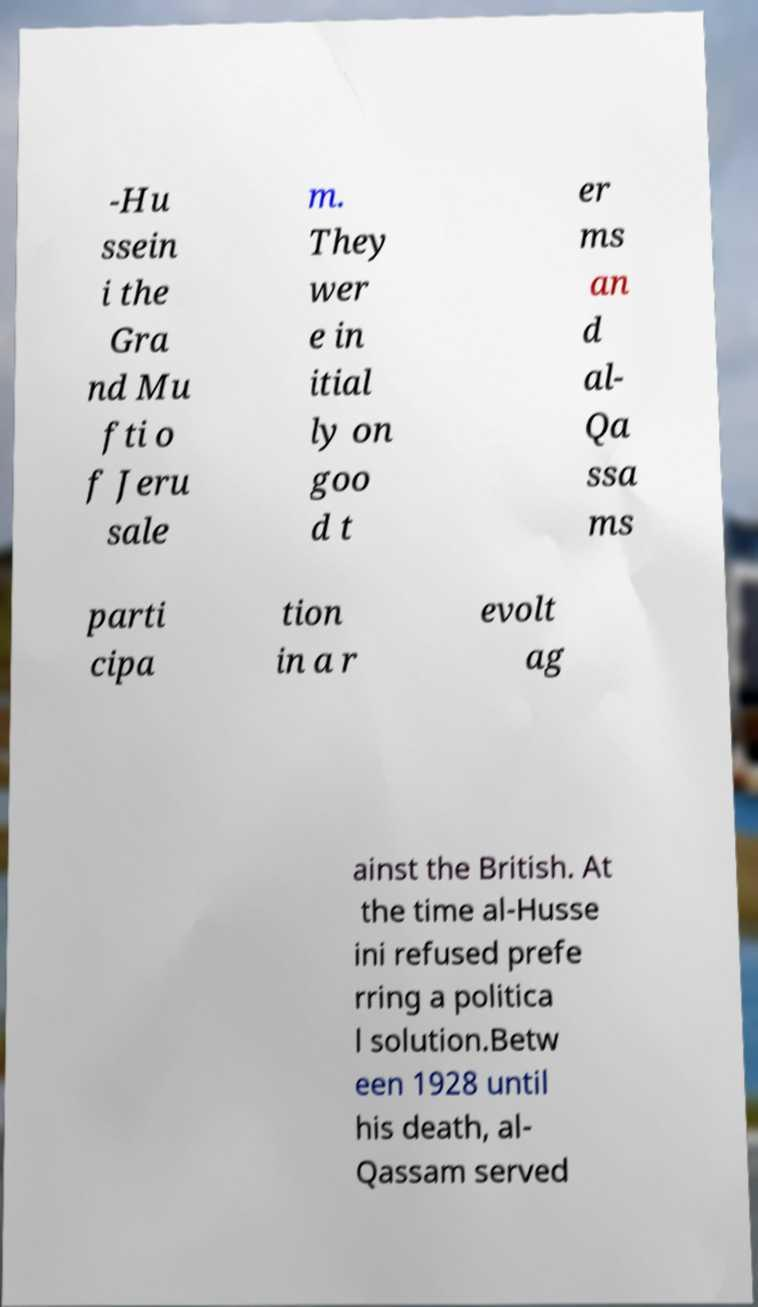Could you extract and type out the text from this image? -Hu ssein i the Gra nd Mu fti o f Jeru sale m. They wer e in itial ly on goo d t er ms an d al- Qa ssa ms parti cipa tion in a r evolt ag ainst the British. At the time al-Husse ini refused prefe rring a politica l solution.Betw een 1928 until his death, al- Qassam served 